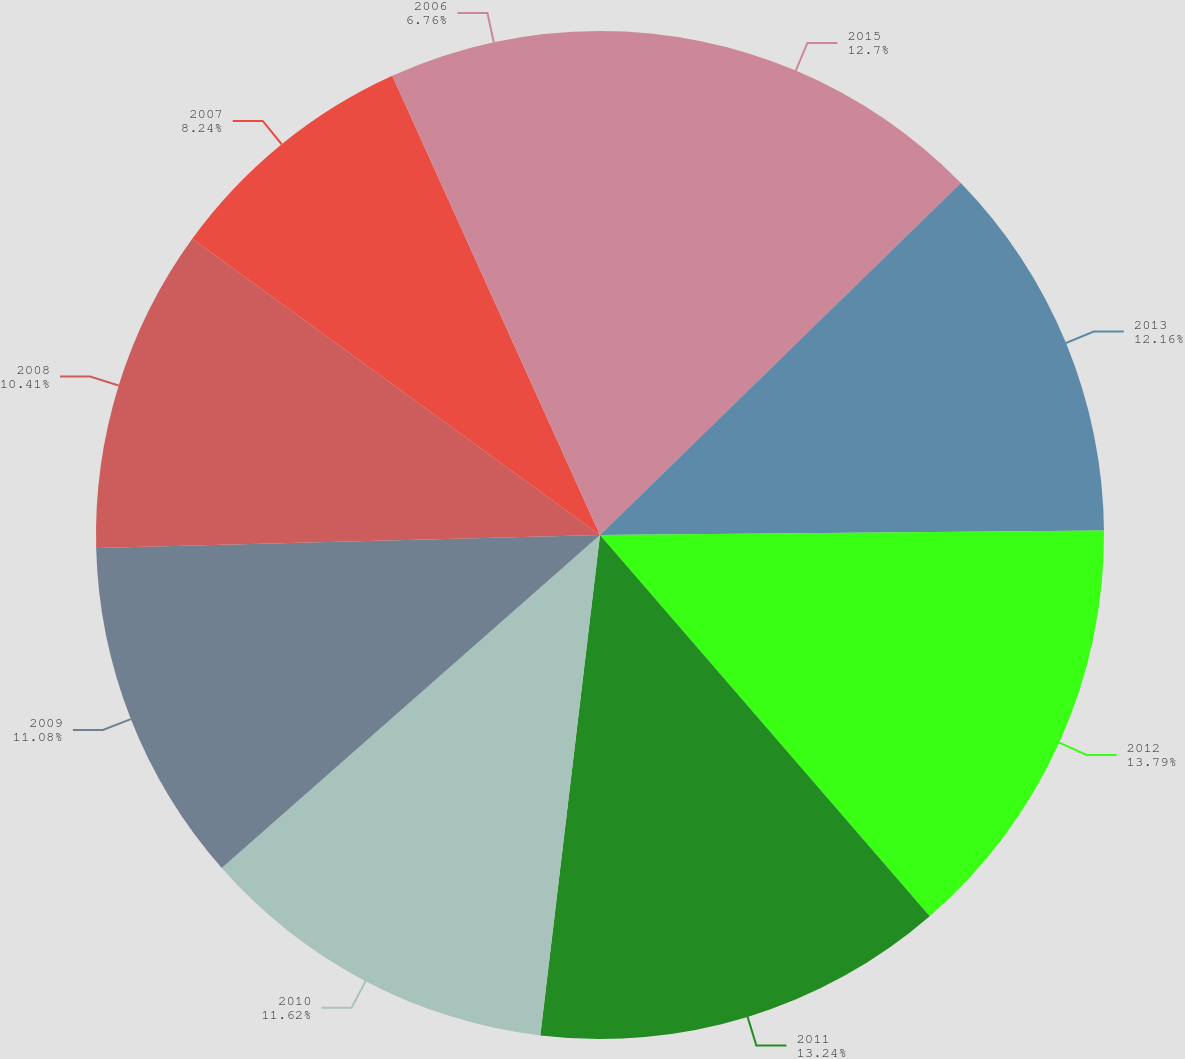<chart> <loc_0><loc_0><loc_500><loc_500><pie_chart><fcel>2015<fcel>2013<fcel>2012<fcel>2011<fcel>2010<fcel>2009<fcel>2008<fcel>2007<fcel>2006<nl><fcel>12.7%<fcel>12.16%<fcel>13.79%<fcel>13.24%<fcel>11.62%<fcel>11.08%<fcel>10.41%<fcel>8.24%<fcel>6.76%<nl></chart> 